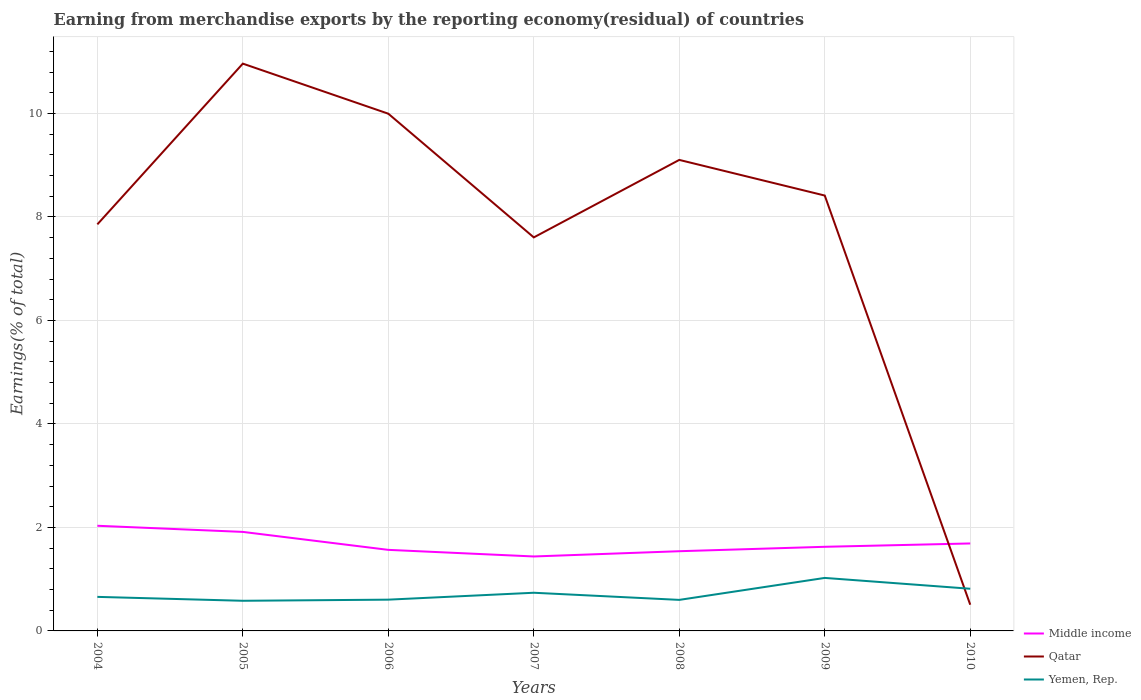Does the line corresponding to Qatar intersect with the line corresponding to Middle income?
Provide a short and direct response. Yes. Is the number of lines equal to the number of legend labels?
Keep it short and to the point. Yes. Across all years, what is the maximum percentage of amount earned from merchandise exports in Middle income?
Ensure brevity in your answer.  1.44. What is the total percentage of amount earned from merchandise exports in Yemen, Rep. in the graph?
Your answer should be very brief. -0.37. What is the difference between the highest and the second highest percentage of amount earned from merchandise exports in Middle income?
Offer a very short reply. 0.59. How many lines are there?
Offer a terse response. 3. What is the difference between two consecutive major ticks on the Y-axis?
Provide a succinct answer. 2. Are the values on the major ticks of Y-axis written in scientific E-notation?
Make the answer very short. No. Does the graph contain any zero values?
Your answer should be compact. No. Does the graph contain grids?
Offer a terse response. Yes. Where does the legend appear in the graph?
Offer a very short reply. Bottom right. How many legend labels are there?
Offer a very short reply. 3. What is the title of the graph?
Give a very brief answer. Earning from merchandise exports by the reporting economy(residual) of countries. What is the label or title of the Y-axis?
Provide a short and direct response. Earnings(% of total). What is the Earnings(% of total) of Middle income in 2004?
Keep it short and to the point. 2.03. What is the Earnings(% of total) in Qatar in 2004?
Make the answer very short. 7.86. What is the Earnings(% of total) of Yemen, Rep. in 2004?
Ensure brevity in your answer.  0.66. What is the Earnings(% of total) of Middle income in 2005?
Keep it short and to the point. 1.91. What is the Earnings(% of total) in Qatar in 2005?
Your response must be concise. 10.96. What is the Earnings(% of total) in Yemen, Rep. in 2005?
Offer a terse response. 0.58. What is the Earnings(% of total) of Middle income in 2006?
Your answer should be very brief. 1.57. What is the Earnings(% of total) of Qatar in 2006?
Provide a short and direct response. 9.99. What is the Earnings(% of total) of Yemen, Rep. in 2006?
Your answer should be compact. 0.6. What is the Earnings(% of total) in Middle income in 2007?
Your answer should be compact. 1.44. What is the Earnings(% of total) in Qatar in 2007?
Provide a short and direct response. 7.6. What is the Earnings(% of total) in Yemen, Rep. in 2007?
Provide a succinct answer. 0.74. What is the Earnings(% of total) of Middle income in 2008?
Keep it short and to the point. 1.54. What is the Earnings(% of total) of Qatar in 2008?
Make the answer very short. 9.1. What is the Earnings(% of total) of Yemen, Rep. in 2008?
Provide a short and direct response. 0.6. What is the Earnings(% of total) in Middle income in 2009?
Your response must be concise. 1.63. What is the Earnings(% of total) in Qatar in 2009?
Provide a short and direct response. 8.41. What is the Earnings(% of total) of Yemen, Rep. in 2009?
Ensure brevity in your answer.  1.02. What is the Earnings(% of total) in Middle income in 2010?
Make the answer very short. 1.69. What is the Earnings(% of total) in Qatar in 2010?
Your answer should be very brief. 0.51. What is the Earnings(% of total) in Yemen, Rep. in 2010?
Give a very brief answer. 0.81. Across all years, what is the maximum Earnings(% of total) of Middle income?
Provide a short and direct response. 2.03. Across all years, what is the maximum Earnings(% of total) of Qatar?
Your answer should be compact. 10.96. Across all years, what is the maximum Earnings(% of total) of Yemen, Rep.?
Make the answer very short. 1.02. Across all years, what is the minimum Earnings(% of total) of Middle income?
Provide a short and direct response. 1.44. Across all years, what is the minimum Earnings(% of total) in Qatar?
Give a very brief answer. 0.51. Across all years, what is the minimum Earnings(% of total) of Yemen, Rep.?
Offer a terse response. 0.58. What is the total Earnings(% of total) in Middle income in the graph?
Provide a succinct answer. 11.81. What is the total Earnings(% of total) of Qatar in the graph?
Your answer should be very brief. 54.44. What is the total Earnings(% of total) in Yemen, Rep. in the graph?
Provide a succinct answer. 5.02. What is the difference between the Earnings(% of total) of Middle income in 2004 and that in 2005?
Offer a terse response. 0.12. What is the difference between the Earnings(% of total) in Qatar in 2004 and that in 2005?
Provide a short and direct response. -3.11. What is the difference between the Earnings(% of total) in Yemen, Rep. in 2004 and that in 2005?
Make the answer very short. 0.08. What is the difference between the Earnings(% of total) in Middle income in 2004 and that in 2006?
Offer a very short reply. 0.47. What is the difference between the Earnings(% of total) in Qatar in 2004 and that in 2006?
Your answer should be very brief. -2.14. What is the difference between the Earnings(% of total) in Yemen, Rep. in 2004 and that in 2006?
Make the answer very short. 0.05. What is the difference between the Earnings(% of total) in Middle income in 2004 and that in 2007?
Make the answer very short. 0.59. What is the difference between the Earnings(% of total) in Qatar in 2004 and that in 2007?
Give a very brief answer. 0.25. What is the difference between the Earnings(% of total) of Yemen, Rep. in 2004 and that in 2007?
Ensure brevity in your answer.  -0.08. What is the difference between the Earnings(% of total) of Middle income in 2004 and that in 2008?
Provide a short and direct response. 0.49. What is the difference between the Earnings(% of total) of Qatar in 2004 and that in 2008?
Provide a succinct answer. -1.25. What is the difference between the Earnings(% of total) in Yemen, Rep. in 2004 and that in 2008?
Your response must be concise. 0.06. What is the difference between the Earnings(% of total) of Middle income in 2004 and that in 2009?
Your answer should be compact. 0.41. What is the difference between the Earnings(% of total) in Qatar in 2004 and that in 2009?
Provide a short and direct response. -0.56. What is the difference between the Earnings(% of total) in Yemen, Rep. in 2004 and that in 2009?
Your response must be concise. -0.37. What is the difference between the Earnings(% of total) in Middle income in 2004 and that in 2010?
Offer a terse response. 0.34. What is the difference between the Earnings(% of total) in Qatar in 2004 and that in 2010?
Offer a very short reply. 7.35. What is the difference between the Earnings(% of total) of Yemen, Rep. in 2004 and that in 2010?
Provide a short and direct response. -0.16. What is the difference between the Earnings(% of total) of Middle income in 2005 and that in 2006?
Your answer should be very brief. 0.35. What is the difference between the Earnings(% of total) of Qatar in 2005 and that in 2006?
Offer a terse response. 0.97. What is the difference between the Earnings(% of total) of Yemen, Rep. in 2005 and that in 2006?
Ensure brevity in your answer.  -0.02. What is the difference between the Earnings(% of total) of Middle income in 2005 and that in 2007?
Provide a succinct answer. 0.47. What is the difference between the Earnings(% of total) in Qatar in 2005 and that in 2007?
Make the answer very short. 3.36. What is the difference between the Earnings(% of total) in Yemen, Rep. in 2005 and that in 2007?
Your answer should be very brief. -0.16. What is the difference between the Earnings(% of total) in Middle income in 2005 and that in 2008?
Ensure brevity in your answer.  0.37. What is the difference between the Earnings(% of total) in Qatar in 2005 and that in 2008?
Make the answer very short. 1.86. What is the difference between the Earnings(% of total) in Yemen, Rep. in 2005 and that in 2008?
Your answer should be very brief. -0.02. What is the difference between the Earnings(% of total) in Middle income in 2005 and that in 2009?
Keep it short and to the point. 0.29. What is the difference between the Earnings(% of total) in Qatar in 2005 and that in 2009?
Provide a short and direct response. 2.55. What is the difference between the Earnings(% of total) in Yemen, Rep. in 2005 and that in 2009?
Your response must be concise. -0.44. What is the difference between the Earnings(% of total) of Middle income in 2005 and that in 2010?
Give a very brief answer. 0.22. What is the difference between the Earnings(% of total) of Qatar in 2005 and that in 2010?
Keep it short and to the point. 10.46. What is the difference between the Earnings(% of total) in Yemen, Rep. in 2005 and that in 2010?
Make the answer very short. -0.23. What is the difference between the Earnings(% of total) of Middle income in 2006 and that in 2007?
Provide a short and direct response. 0.13. What is the difference between the Earnings(% of total) of Qatar in 2006 and that in 2007?
Your answer should be very brief. 2.39. What is the difference between the Earnings(% of total) of Yemen, Rep. in 2006 and that in 2007?
Your response must be concise. -0.13. What is the difference between the Earnings(% of total) in Middle income in 2006 and that in 2008?
Provide a succinct answer. 0.03. What is the difference between the Earnings(% of total) of Qatar in 2006 and that in 2008?
Provide a short and direct response. 0.89. What is the difference between the Earnings(% of total) in Yemen, Rep. in 2006 and that in 2008?
Provide a short and direct response. 0. What is the difference between the Earnings(% of total) in Middle income in 2006 and that in 2009?
Keep it short and to the point. -0.06. What is the difference between the Earnings(% of total) in Qatar in 2006 and that in 2009?
Your answer should be very brief. 1.58. What is the difference between the Earnings(% of total) of Yemen, Rep. in 2006 and that in 2009?
Your answer should be compact. -0.42. What is the difference between the Earnings(% of total) of Middle income in 2006 and that in 2010?
Provide a short and direct response. -0.12. What is the difference between the Earnings(% of total) of Qatar in 2006 and that in 2010?
Keep it short and to the point. 9.49. What is the difference between the Earnings(% of total) in Yemen, Rep. in 2006 and that in 2010?
Your answer should be compact. -0.21. What is the difference between the Earnings(% of total) of Middle income in 2007 and that in 2008?
Make the answer very short. -0.1. What is the difference between the Earnings(% of total) in Qatar in 2007 and that in 2008?
Ensure brevity in your answer.  -1.5. What is the difference between the Earnings(% of total) in Yemen, Rep. in 2007 and that in 2008?
Your answer should be compact. 0.14. What is the difference between the Earnings(% of total) of Middle income in 2007 and that in 2009?
Keep it short and to the point. -0.19. What is the difference between the Earnings(% of total) in Qatar in 2007 and that in 2009?
Your answer should be very brief. -0.81. What is the difference between the Earnings(% of total) in Yemen, Rep. in 2007 and that in 2009?
Keep it short and to the point. -0.29. What is the difference between the Earnings(% of total) in Middle income in 2007 and that in 2010?
Your response must be concise. -0.25. What is the difference between the Earnings(% of total) in Qatar in 2007 and that in 2010?
Keep it short and to the point. 7.1. What is the difference between the Earnings(% of total) of Yemen, Rep. in 2007 and that in 2010?
Ensure brevity in your answer.  -0.08. What is the difference between the Earnings(% of total) of Middle income in 2008 and that in 2009?
Offer a very short reply. -0.09. What is the difference between the Earnings(% of total) in Qatar in 2008 and that in 2009?
Offer a terse response. 0.69. What is the difference between the Earnings(% of total) of Yemen, Rep. in 2008 and that in 2009?
Provide a succinct answer. -0.42. What is the difference between the Earnings(% of total) in Middle income in 2008 and that in 2010?
Give a very brief answer. -0.15. What is the difference between the Earnings(% of total) of Qatar in 2008 and that in 2010?
Provide a succinct answer. 8.6. What is the difference between the Earnings(% of total) in Yemen, Rep. in 2008 and that in 2010?
Make the answer very short. -0.22. What is the difference between the Earnings(% of total) in Middle income in 2009 and that in 2010?
Your answer should be very brief. -0.06. What is the difference between the Earnings(% of total) in Qatar in 2009 and that in 2010?
Your response must be concise. 7.91. What is the difference between the Earnings(% of total) in Yemen, Rep. in 2009 and that in 2010?
Make the answer very short. 0.21. What is the difference between the Earnings(% of total) in Middle income in 2004 and the Earnings(% of total) in Qatar in 2005?
Keep it short and to the point. -8.93. What is the difference between the Earnings(% of total) of Middle income in 2004 and the Earnings(% of total) of Yemen, Rep. in 2005?
Your answer should be very brief. 1.45. What is the difference between the Earnings(% of total) of Qatar in 2004 and the Earnings(% of total) of Yemen, Rep. in 2005?
Make the answer very short. 7.27. What is the difference between the Earnings(% of total) in Middle income in 2004 and the Earnings(% of total) in Qatar in 2006?
Offer a very short reply. -7.96. What is the difference between the Earnings(% of total) in Middle income in 2004 and the Earnings(% of total) in Yemen, Rep. in 2006?
Your answer should be compact. 1.43. What is the difference between the Earnings(% of total) of Qatar in 2004 and the Earnings(% of total) of Yemen, Rep. in 2006?
Ensure brevity in your answer.  7.25. What is the difference between the Earnings(% of total) in Middle income in 2004 and the Earnings(% of total) in Qatar in 2007?
Keep it short and to the point. -5.57. What is the difference between the Earnings(% of total) in Middle income in 2004 and the Earnings(% of total) in Yemen, Rep. in 2007?
Offer a very short reply. 1.29. What is the difference between the Earnings(% of total) in Qatar in 2004 and the Earnings(% of total) in Yemen, Rep. in 2007?
Offer a terse response. 7.12. What is the difference between the Earnings(% of total) in Middle income in 2004 and the Earnings(% of total) in Qatar in 2008?
Your answer should be very brief. -7.07. What is the difference between the Earnings(% of total) of Middle income in 2004 and the Earnings(% of total) of Yemen, Rep. in 2008?
Your answer should be very brief. 1.43. What is the difference between the Earnings(% of total) in Qatar in 2004 and the Earnings(% of total) in Yemen, Rep. in 2008?
Provide a short and direct response. 7.26. What is the difference between the Earnings(% of total) in Middle income in 2004 and the Earnings(% of total) in Qatar in 2009?
Offer a very short reply. -6.38. What is the difference between the Earnings(% of total) of Middle income in 2004 and the Earnings(% of total) of Yemen, Rep. in 2009?
Offer a very short reply. 1.01. What is the difference between the Earnings(% of total) in Qatar in 2004 and the Earnings(% of total) in Yemen, Rep. in 2009?
Offer a terse response. 6.83. What is the difference between the Earnings(% of total) of Middle income in 2004 and the Earnings(% of total) of Qatar in 2010?
Give a very brief answer. 1.53. What is the difference between the Earnings(% of total) of Middle income in 2004 and the Earnings(% of total) of Yemen, Rep. in 2010?
Give a very brief answer. 1.22. What is the difference between the Earnings(% of total) in Qatar in 2004 and the Earnings(% of total) in Yemen, Rep. in 2010?
Your answer should be very brief. 7.04. What is the difference between the Earnings(% of total) in Middle income in 2005 and the Earnings(% of total) in Qatar in 2006?
Keep it short and to the point. -8.08. What is the difference between the Earnings(% of total) of Middle income in 2005 and the Earnings(% of total) of Yemen, Rep. in 2006?
Ensure brevity in your answer.  1.31. What is the difference between the Earnings(% of total) of Qatar in 2005 and the Earnings(% of total) of Yemen, Rep. in 2006?
Offer a terse response. 10.36. What is the difference between the Earnings(% of total) of Middle income in 2005 and the Earnings(% of total) of Qatar in 2007?
Make the answer very short. -5.69. What is the difference between the Earnings(% of total) in Middle income in 2005 and the Earnings(% of total) in Yemen, Rep. in 2007?
Your response must be concise. 1.18. What is the difference between the Earnings(% of total) in Qatar in 2005 and the Earnings(% of total) in Yemen, Rep. in 2007?
Provide a succinct answer. 10.22. What is the difference between the Earnings(% of total) in Middle income in 2005 and the Earnings(% of total) in Qatar in 2008?
Offer a very short reply. -7.19. What is the difference between the Earnings(% of total) in Middle income in 2005 and the Earnings(% of total) in Yemen, Rep. in 2008?
Provide a succinct answer. 1.31. What is the difference between the Earnings(% of total) of Qatar in 2005 and the Earnings(% of total) of Yemen, Rep. in 2008?
Give a very brief answer. 10.36. What is the difference between the Earnings(% of total) of Middle income in 2005 and the Earnings(% of total) of Qatar in 2009?
Your answer should be very brief. -6.5. What is the difference between the Earnings(% of total) of Middle income in 2005 and the Earnings(% of total) of Yemen, Rep. in 2009?
Make the answer very short. 0.89. What is the difference between the Earnings(% of total) in Qatar in 2005 and the Earnings(% of total) in Yemen, Rep. in 2009?
Give a very brief answer. 9.94. What is the difference between the Earnings(% of total) of Middle income in 2005 and the Earnings(% of total) of Qatar in 2010?
Keep it short and to the point. 1.41. What is the difference between the Earnings(% of total) in Middle income in 2005 and the Earnings(% of total) in Yemen, Rep. in 2010?
Provide a succinct answer. 1.1. What is the difference between the Earnings(% of total) in Qatar in 2005 and the Earnings(% of total) in Yemen, Rep. in 2010?
Provide a succinct answer. 10.15. What is the difference between the Earnings(% of total) of Middle income in 2006 and the Earnings(% of total) of Qatar in 2007?
Ensure brevity in your answer.  -6.04. What is the difference between the Earnings(% of total) of Middle income in 2006 and the Earnings(% of total) of Yemen, Rep. in 2007?
Offer a terse response. 0.83. What is the difference between the Earnings(% of total) of Qatar in 2006 and the Earnings(% of total) of Yemen, Rep. in 2007?
Provide a succinct answer. 9.26. What is the difference between the Earnings(% of total) of Middle income in 2006 and the Earnings(% of total) of Qatar in 2008?
Give a very brief answer. -7.54. What is the difference between the Earnings(% of total) of Middle income in 2006 and the Earnings(% of total) of Yemen, Rep. in 2008?
Give a very brief answer. 0.97. What is the difference between the Earnings(% of total) of Qatar in 2006 and the Earnings(% of total) of Yemen, Rep. in 2008?
Keep it short and to the point. 9.39. What is the difference between the Earnings(% of total) of Middle income in 2006 and the Earnings(% of total) of Qatar in 2009?
Ensure brevity in your answer.  -6.85. What is the difference between the Earnings(% of total) of Middle income in 2006 and the Earnings(% of total) of Yemen, Rep. in 2009?
Your answer should be very brief. 0.54. What is the difference between the Earnings(% of total) in Qatar in 2006 and the Earnings(% of total) in Yemen, Rep. in 2009?
Offer a very short reply. 8.97. What is the difference between the Earnings(% of total) of Middle income in 2006 and the Earnings(% of total) of Qatar in 2010?
Offer a very short reply. 1.06. What is the difference between the Earnings(% of total) of Middle income in 2006 and the Earnings(% of total) of Yemen, Rep. in 2010?
Provide a succinct answer. 0.75. What is the difference between the Earnings(% of total) of Qatar in 2006 and the Earnings(% of total) of Yemen, Rep. in 2010?
Provide a short and direct response. 9.18. What is the difference between the Earnings(% of total) of Middle income in 2007 and the Earnings(% of total) of Qatar in 2008?
Give a very brief answer. -7.66. What is the difference between the Earnings(% of total) in Middle income in 2007 and the Earnings(% of total) in Yemen, Rep. in 2008?
Offer a very short reply. 0.84. What is the difference between the Earnings(% of total) in Qatar in 2007 and the Earnings(% of total) in Yemen, Rep. in 2008?
Your response must be concise. 7. What is the difference between the Earnings(% of total) in Middle income in 2007 and the Earnings(% of total) in Qatar in 2009?
Your answer should be compact. -6.97. What is the difference between the Earnings(% of total) of Middle income in 2007 and the Earnings(% of total) of Yemen, Rep. in 2009?
Give a very brief answer. 0.41. What is the difference between the Earnings(% of total) in Qatar in 2007 and the Earnings(% of total) in Yemen, Rep. in 2009?
Offer a very short reply. 6.58. What is the difference between the Earnings(% of total) of Middle income in 2007 and the Earnings(% of total) of Qatar in 2010?
Your answer should be very brief. 0.93. What is the difference between the Earnings(% of total) of Middle income in 2007 and the Earnings(% of total) of Yemen, Rep. in 2010?
Provide a short and direct response. 0.62. What is the difference between the Earnings(% of total) of Qatar in 2007 and the Earnings(% of total) of Yemen, Rep. in 2010?
Provide a short and direct response. 6.79. What is the difference between the Earnings(% of total) of Middle income in 2008 and the Earnings(% of total) of Qatar in 2009?
Offer a very short reply. -6.87. What is the difference between the Earnings(% of total) in Middle income in 2008 and the Earnings(% of total) in Yemen, Rep. in 2009?
Keep it short and to the point. 0.52. What is the difference between the Earnings(% of total) of Qatar in 2008 and the Earnings(% of total) of Yemen, Rep. in 2009?
Ensure brevity in your answer.  8.08. What is the difference between the Earnings(% of total) of Middle income in 2008 and the Earnings(% of total) of Qatar in 2010?
Offer a very short reply. 1.03. What is the difference between the Earnings(% of total) of Middle income in 2008 and the Earnings(% of total) of Yemen, Rep. in 2010?
Ensure brevity in your answer.  0.73. What is the difference between the Earnings(% of total) in Qatar in 2008 and the Earnings(% of total) in Yemen, Rep. in 2010?
Give a very brief answer. 8.29. What is the difference between the Earnings(% of total) of Middle income in 2009 and the Earnings(% of total) of Qatar in 2010?
Provide a succinct answer. 1.12. What is the difference between the Earnings(% of total) in Middle income in 2009 and the Earnings(% of total) in Yemen, Rep. in 2010?
Offer a terse response. 0.81. What is the difference between the Earnings(% of total) of Qatar in 2009 and the Earnings(% of total) of Yemen, Rep. in 2010?
Your response must be concise. 7.6. What is the average Earnings(% of total) of Middle income per year?
Your response must be concise. 1.69. What is the average Earnings(% of total) of Qatar per year?
Make the answer very short. 7.78. What is the average Earnings(% of total) of Yemen, Rep. per year?
Make the answer very short. 0.72. In the year 2004, what is the difference between the Earnings(% of total) of Middle income and Earnings(% of total) of Qatar?
Give a very brief answer. -5.82. In the year 2004, what is the difference between the Earnings(% of total) in Middle income and Earnings(% of total) in Yemen, Rep.?
Provide a short and direct response. 1.37. In the year 2004, what is the difference between the Earnings(% of total) in Qatar and Earnings(% of total) in Yemen, Rep.?
Your response must be concise. 7.2. In the year 2005, what is the difference between the Earnings(% of total) of Middle income and Earnings(% of total) of Qatar?
Your response must be concise. -9.05. In the year 2005, what is the difference between the Earnings(% of total) in Middle income and Earnings(% of total) in Yemen, Rep.?
Your answer should be compact. 1.33. In the year 2005, what is the difference between the Earnings(% of total) in Qatar and Earnings(% of total) in Yemen, Rep.?
Keep it short and to the point. 10.38. In the year 2006, what is the difference between the Earnings(% of total) of Middle income and Earnings(% of total) of Qatar?
Your answer should be very brief. -8.43. In the year 2006, what is the difference between the Earnings(% of total) in Qatar and Earnings(% of total) in Yemen, Rep.?
Your response must be concise. 9.39. In the year 2007, what is the difference between the Earnings(% of total) of Middle income and Earnings(% of total) of Qatar?
Offer a terse response. -6.17. In the year 2007, what is the difference between the Earnings(% of total) of Middle income and Earnings(% of total) of Yemen, Rep.?
Give a very brief answer. 0.7. In the year 2007, what is the difference between the Earnings(% of total) of Qatar and Earnings(% of total) of Yemen, Rep.?
Your answer should be compact. 6.87. In the year 2008, what is the difference between the Earnings(% of total) in Middle income and Earnings(% of total) in Qatar?
Offer a very short reply. -7.56. In the year 2008, what is the difference between the Earnings(% of total) of Middle income and Earnings(% of total) of Yemen, Rep.?
Keep it short and to the point. 0.94. In the year 2008, what is the difference between the Earnings(% of total) of Qatar and Earnings(% of total) of Yemen, Rep.?
Ensure brevity in your answer.  8.5. In the year 2009, what is the difference between the Earnings(% of total) of Middle income and Earnings(% of total) of Qatar?
Provide a short and direct response. -6.79. In the year 2009, what is the difference between the Earnings(% of total) in Middle income and Earnings(% of total) in Yemen, Rep.?
Provide a short and direct response. 0.6. In the year 2009, what is the difference between the Earnings(% of total) of Qatar and Earnings(% of total) of Yemen, Rep.?
Ensure brevity in your answer.  7.39. In the year 2010, what is the difference between the Earnings(% of total) in Middle income and Earnings(% of total) in Qatar?
Offer a very short reply. 1.18. In the year 2010, what is the difference between the Earnings(% of total) in Middle income and Earnings(% of total) in Yemen, Rep.?
Ensure brevity in your answer.  0.88. In the year 2010, what is the difference between the Earnings(% of total) of Qatar and Earnings(% of total) of Yemen, Rep.?
Your response must be concise. -0.31. What is the ratio of the Earnings(% of total) in Middle income in 2004 to that in 2005?
Offer a very short reply. 1.06. What is the ratio of the Earnings(% of total) in Qatar in 2004 to that in 2005?
Provide a short and direct response. 0.72. What is the ratio of the Earnings(% of total) of Yemen, Rep. in 2004 to that in 2005?
Your response must be concise. 1.13. What is the ratio of the Earnings(% of total) in Middle income in 2004 to that in 2006?
Provide a succinct answer. 1.3. What is the ratio of the Earnings(% of total) in Qatar in 2004 to that in 2006?
Provide a short and direct response. 0.79. What is the ratio of the Earnings(% of total) of Yemen, Rep. in 2004 to that in 2006?
Provide a short and direct response. 1.09. What is the ratio of the Earnings(% of total) of Middle income in 2004 to that in 2007?
Make the answer very short. 1.41. What is the ratio of the Earnings(% of total) of Qatar in 2004 to that in 2007?
Your answer should be compact. 1.03. What is the ratio of the Earnings(% of total) of Yemen, Rep. in 2004 to that in 2007?
Offer a very short reply. 0.89. What is the ratio of the Earnings(% of total) of Middle income in 2004 to that in 2008?
Offer a very short reply. 1.32. What is the ratio of the Earnings(% of total) in Qatar in 2004 to that in 2008?
Give a very brief answer. 0.86. What is the ratio of the Earnings(% of total) of Yemen, Rep. in 2004 to that in 2008?
Make the answer very short. 1.1. What is the ratio of the Earnings(% of total) in Middle income in 2004 to that in 2009?
Your answer should be compact. 1.25. What is the ratio of the Earnings(% of total) of Qatar in 2004 to that in 2009?
Ensure brevity in your answer.  0.93. What is the ratio of the Earnings(% of total) of Yemen, Rep. in 2004 to that in 2009?
Offer a terse response. 0.64. What is the ratio of the Earnings(% of total) of Middle income in 2004 to that in 2010?
Keep it short and to the point. 1.2. What is the ratio of the Earnings(% of total) in Qatar in 2004 to that in 2010?
Make the answer very short. 15.51. What is the ratio of the Earnings(% of total) in Yemen, Rep. in 2004 to that in 2010?
Make the answer very short. 0.81. What is the ratio of the Earnings(% of total) in Middle income in 2005 to that in 2006?
Your answer should be very brief. 1.22. What is the ratio of the Earnings(% of total) of Qatar in 2005 to that in 2006?
Provide a succinct answer. 1.1. What is the ratio of the Earnings(% of total) in Yemen, Rep. in 2005 to that in 2006?
Give a very brief answer. 0.96. What is the ratio of the Earnings(% of total) in Middle income in 2005 to that in 2007?
Give a very brief answer. 1.33. What is the ratio of the Earnings(% of total) of Qatar in 2005 to that in 2007?
Offer a terse response. 1.44. What is the ratio of the Earnings(% of total) in Yemen, Rep. in 2005 to that in 2007?
Provide a short and direct response. 0.79. What is the ratio of the Earnings(% of total) of Middle income in 2005 to that in 2008?
Give a very brief answer. 1.24. What is the ratio of the Earnings(% of total) in Qatar in 2005 to that in 2008?
Provide a short and direct response. 1.2. What is the ratio of the Earnings(% of total) in Yemen, Rep. in 2005 to that in 2008?
Make the answer very short. 0.97. What is the ratio of the Earnings(% of total) of Middle income in 2005 to that in 2009?
Provide a succinct answer. 1.18. What is the ratio of the Earnings(% of total) of Qatar in 2005 to that in 2009?
Provide a succinct answer. 1.3. What is the ratio of the Earnings(% of total) in Yemen, Rep. in 2005 to that in 2009?
Give a very brief answer. 0.57. What is the ratio of the Earnings(% of total) in Middle income in 2005 to that in 2010?
Offer a very short reply. 1.13. What is the ratio of the Earnings(% of total) in Qatar in 2005 to that in 2010?
Give a very brief answer. 21.64. What is the ratio of the Earnings(% of total) in Yemen, Rep. in 2005 to that in 2010?
Offer a very short reply. 0.71. What is the ratio of the Earnings(% of total) of Middle income in 2006 to that in 2007?
Offer a very short reply. 1.09. What is the ratio of the Earnings(% of total) of Qatar in 2006 to that in 2007?
Offer a very short reply. 1.31. What is the ratio of the Earnings(% of total) of Yemen, Rep. in 2006 to that in 2007?
Offer a terse response. 0.82. What is the ratio of the Earnings(% of total) of Qatar in 2006 to that in 2008?
Your answer should be compact. 1.1. What is the ratio of the Earnings(% of total) of Yemen, Rep. in 2006 to that in 2008?
Provide a short and direct response. 1.01. What is the ratio of the Earnings(% of total) of Middle income in 2006 to that in 2009?
Your response must be concise. 0.96. What is the ratio of the Earnings(% of total) of Qatar in 2006 to that in 2009?
Your response must be concise. 1.19. What is the ratio of the Earnings(% of total) in Yemen, Rep. in 2006 to that in 2009?
Make the answer very short. 0.59. What is the ratio of the Earnings(% of total) of Middle income in 2006 to that in 2010?
Provide a short and direct response. 0.93. What is the ratio of the Earnings(% of total) in Qatar in 2006 to that in 2010?
Your answer should be very brief. 19.73. What is the ratio of the Earnings(% of total) of Yemen, Rep. in 2006 to that in 2010?
Make the answer very short. 0.74. What is the ratio of the Earnings(% of total) of Middle income in 2007 to that in 2008?
Provide a short and direct response. 0.93. What is the ratio of the Earnings(% of total) of Qatar in 2007 to that in 2008?
Offer a very short reply. 0.84. What is the ratio of the Earnings(% of total) in Yemen, Rep. in 2007 to that in 2008?
Keep it short and to the point. 1.23. What is the ratio of the Earnings(% of total) in Middle income in 2007 to that in 2009?
Make the answer very short. 0.89. What is the ratio of the Earnings(% of total) of Qatar in 2007 to that in 2009?
Make the answer very short. 0.9. What is the ratio of the Earnings(% of total) in Yemen, Rep. in 2007 to that in 2009?
Offer a very short reply. 0.72. What is the ratio of the Earnings(% of total) of Middle income in 2007 to that in 2010?
Your response must be concise. 0.85. What is the ratio of the Earnings(% of total) of Qatar in 2007 to that in 2010?
Provide a succinct answer. 15.01. What is the ratio of the Earnings(% of total) of Yemen, Rep. in 2007 to that in 2010?
Your answer should be very brief. 0.91. What is the ratio of the Earnings(% of total) in Middle income in 2008 to that in 2009?
Ensure brevity in your answer.  0.95. What is the ratio of the Earnings(% of total) of Qatar in 2008 to that in 2009?
Make the answer very short. 1.08. What is the ratio of the Earnings(% of total) of Yemen, Rep. in 2008 to that in 2009?
Offer a terse response. 0.59. What is the ratio of the Earnings(% of total) in Middle income in 2008 to that in 2010?
Provide a succinct answer. 0.91. What is the ratio of the Earnings(% of total) in Qatar in 2008 to that in 2010?
Provide a succinct answer. 17.97. What is the ratio of the Earnings(% of total) in Yemen, Rep. in 2008 to that in 2010?
Your answer should be very brief. 0.74. What is the ratio of the Earnings(% of total) in Middle income in 2009 to that in 2010?
Offer a terse response. 0.96. What is the ratio of the Earnings(% of total) of Qatar in 2009 to that in 2010?
Your response must be concise. 16.61. What is the ratio of the Earnings(% of total) in Yemen, Rep. in 2009 to that in 2010?
Your answer should be compact. 1.26. What is the difference between the highest and the second highest Earnings(% of total) in Middle income?
Make the answer very short. 0.12. What is the difference between the highest and the second highest Earnings(% of total) in Qatar?
Your answer should be compact. 0.97. What is the difference between the highest and the second highest Earnings(% of total) of Yemen, Rep.?
Keep it short and to the point. 0.21. What is the difference between the highest and the lowest Earnings(% of total) in Middle income?
Provide a short and direct response. 0.59. What is the difference between the highest and the lowest Earnings(% of total) in Qatar?
Offer a very short reply. 10.46. What is the difference between the highest and the lowest Earnings(% of total) of Yemen, Rep.?
Provide a succinct answer. 0.44. 